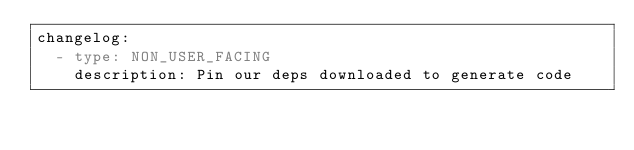Convert code to text. <code><loc_0><loc_0><loc_500><loc_500><_YAML_>changelog:
  - type: NON_USER_FACING
    description: Pin our deps downloaded to generate code</code> 